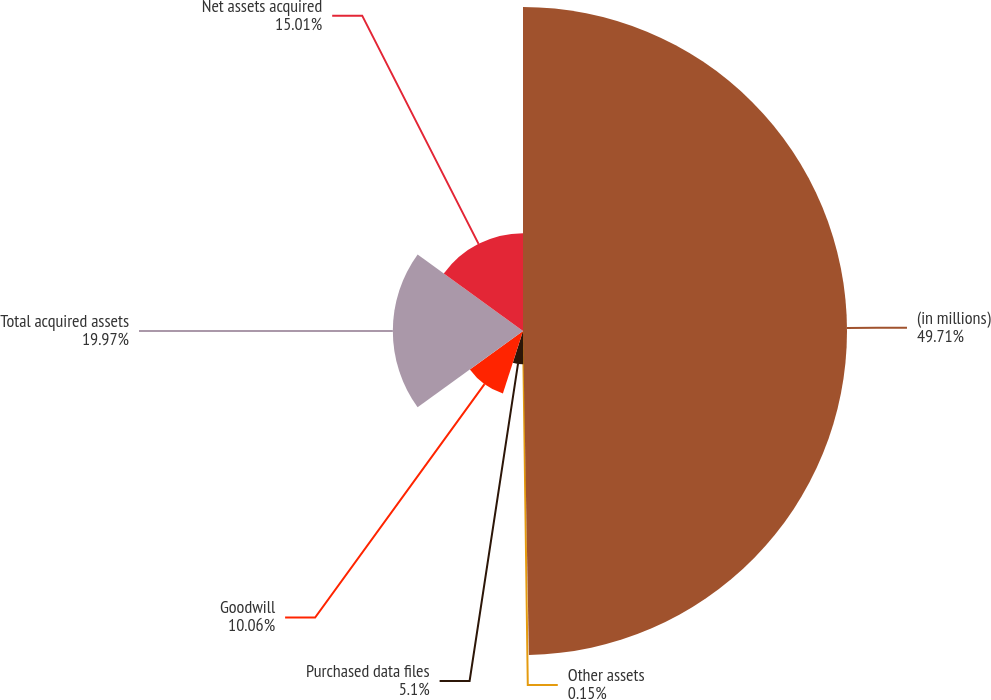<chart> <loc_0><loc_0><loc_500><loc_500><pie_chart><fcel>(in millions)<fcel>Other assets<fcel>Purchased data files<fcel>Goodwill<fcel>Total acquired assets<fcel>Net assets acquired<nl><fcel>49.71%<fcel>0.15%<fcel>5.1%<fcel>10.06%<fcel>19.97%<fcel>15.01%<nl></chart> 